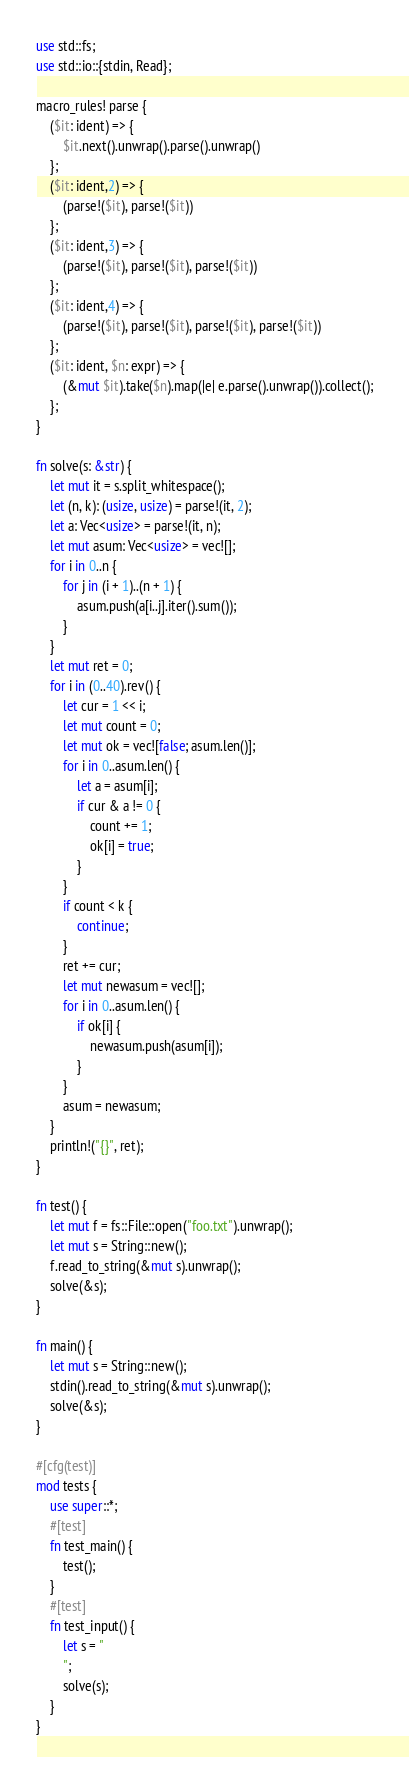<code> <loc_0><loc_0><loc_500><loc_500><_Rust_>use std::fs;
use std::io::{stdin, Read};

macro_rules! parse {
    ($it: ident) => {
        $it.next().unwrap().parse().unwrap()
    };
    ($it: ident,2) => {
        (parse!($it), parse!($it))
    };
    ($it: ident,3) => {
        (parse!($it), parse!($it), parse!($it))
    };
    ($it: ident,4) => {
        (parse!($it), parse!($it), parse!($it), parse!($it))
    };
    ($it: ident, $n: expr) => {
        (&mut $it).take($n).map(|e| e.parse().unwrap()).collect();
    };
}

fn solve(s: &str) {
    let mut it = s.split_whitespace();
    let (n, k): (usize, usize) = parse!(it, 2);
    let a: Vec<usize> = parse!(it, n);
    let mut asum: Vec<usize> = vec![];
    for i in 0..n {
        for j in (i + 1)..(n + 1) {
            asum.push(a[i..j].iter().sum());
        }
    }
    let mut ret = 0;
    for i in (0..40).rev() {
        let cur = 1 << i;
        let mut count = 0;
        let mut ok = vec![false; asum.len()];
        for i in 0..asum.len() {
            let a = asum[i];
            if cur & a != 0 {
                count += 1;
                ok[i] = true;
            }
        }
        if count < k {
            continue;
        }
        ret += cur;
        let mut newasum = vec![];
        for i in 0..asum.len() {
            if ok[i] {
                newasum.push(asum[i]);
            }
        }
        asum = newasum;
    }
    println!("{}", ret);
}

fn test() {
    let mut f = fs::File::open("foo.txt").unwrap();
    let mut s = String::new();
    f.read_to_string(&mut s).unwrap();
    solve(&s);
}

fn main() {
    let mut s = String::new();
    stdin().read_to_string(&mut s).unwrap();
    solve(&s);
}

#[cfg(test)]
mod tests {
    use super::*;
    #[test]
    fn test_main() {
        test();
    }
    #[test]
    fn test_input() {
        let s = "
        ";
        solve(s);
    }
}
</code> 